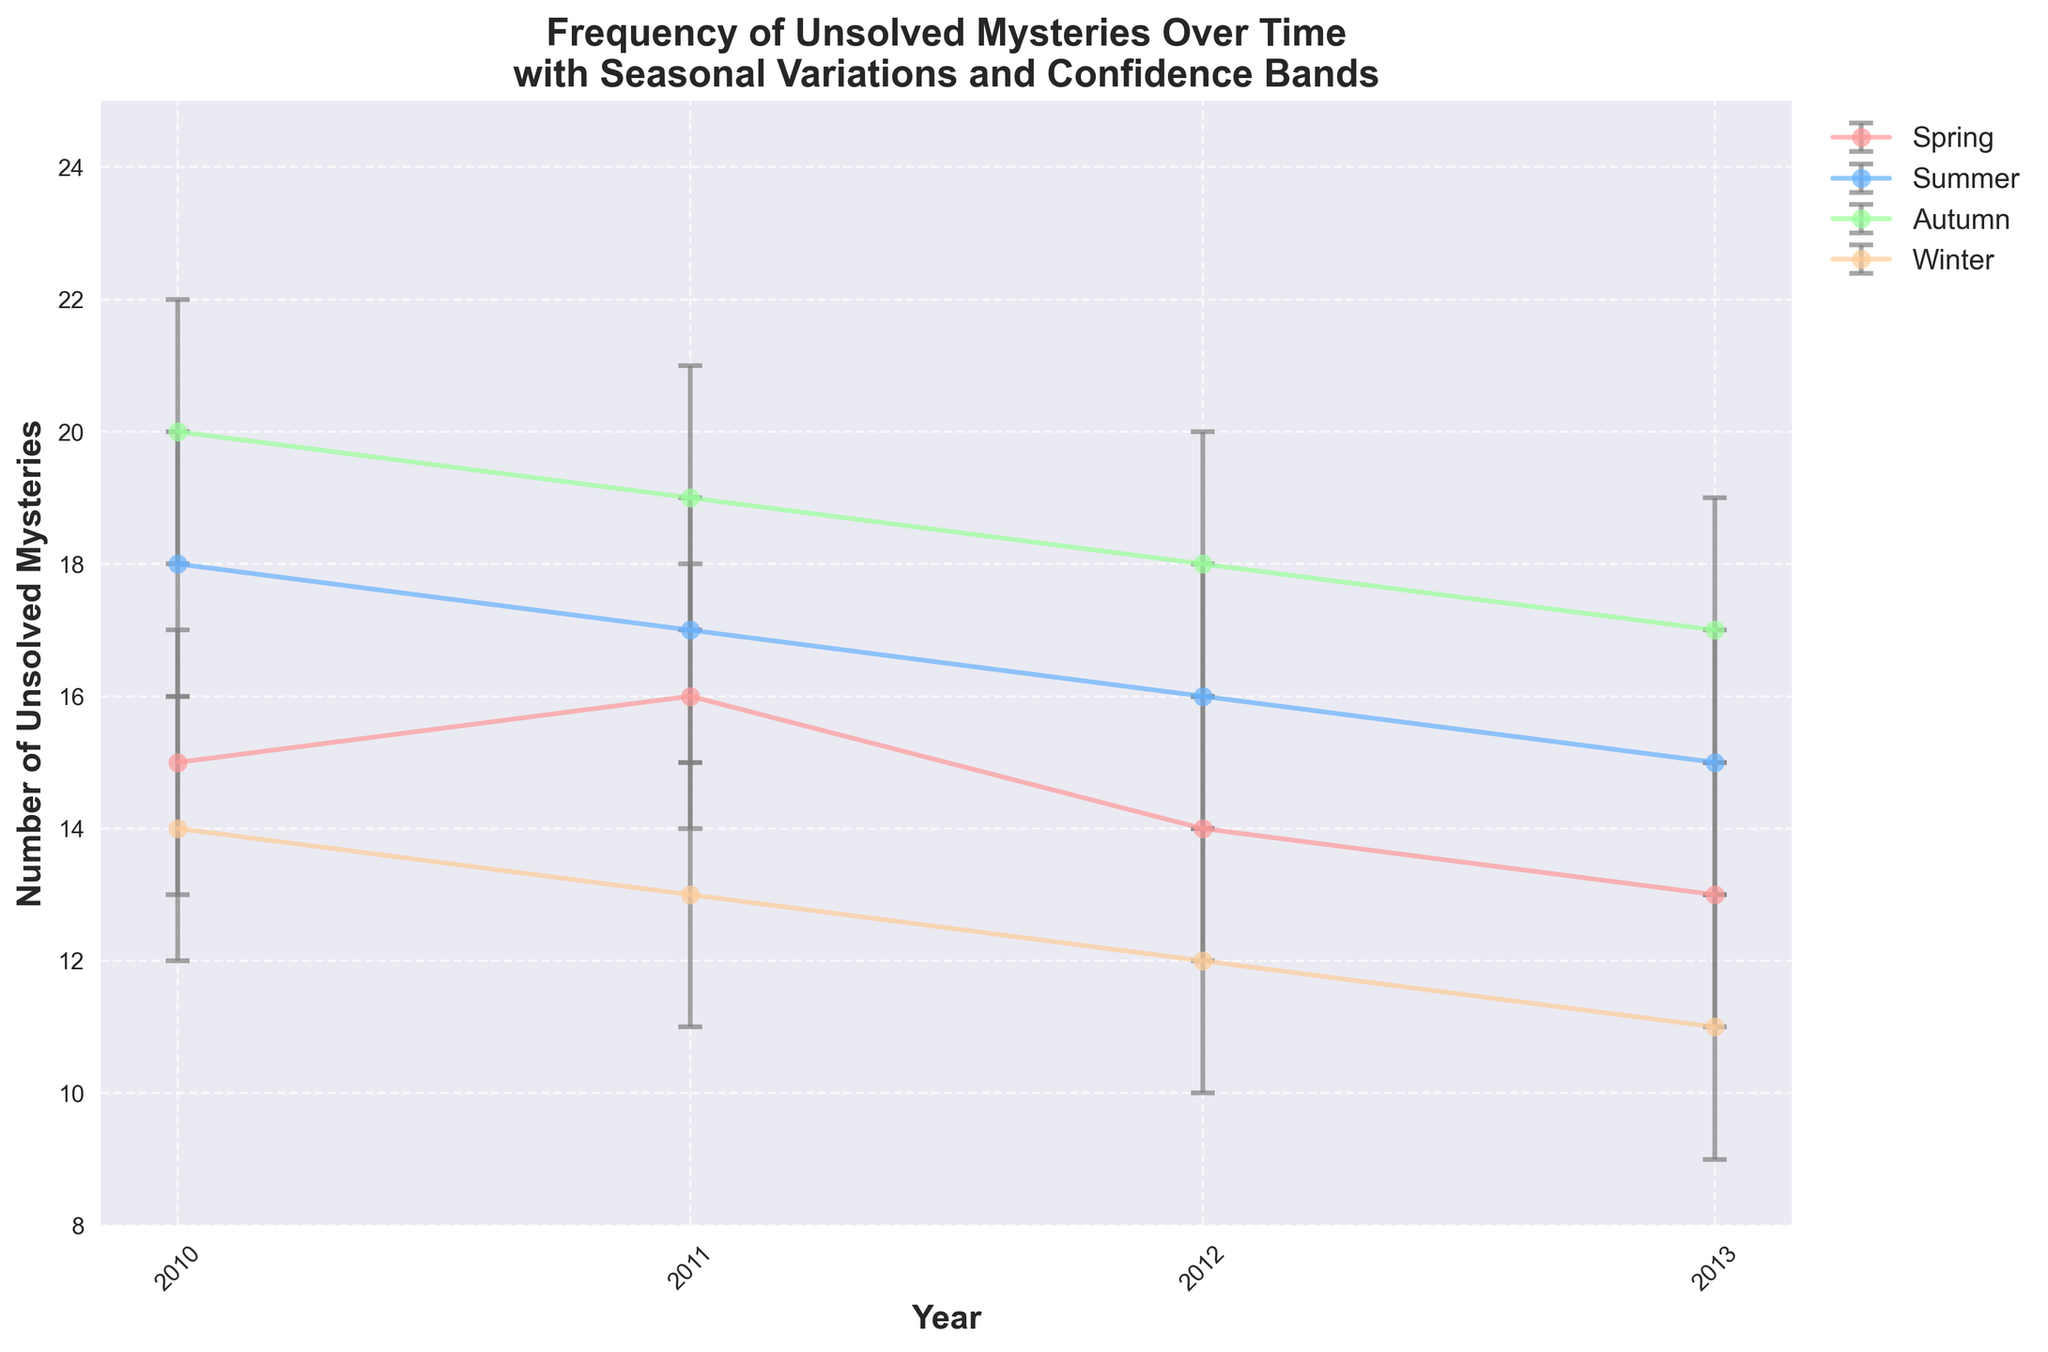What is the title of the figure? The title is at the top center of the figure, showing the overall purpose of the plot.
Answer: Frequency of Unsolved Mysteries Over Time with Seasonal Variations and Confidence Bands What is the y-axis label? Axis labels are typically found next to the respective axis, providing the measurement units and variable names. The y-axis label indicates what is being measured.
Answer: Number of Unsolved Mysteries In which year and season was the highest number of unsolved mysteries recorded? By looking at the peaks of the lines on the plot, find the highest data point and note its corresponding year and season from the legend and x-axis.
Answer: 2010 Autumn What is the general trend of unsolved mysteries in winter from 2010 to 2013? Following the line corresponding to winter, examine if the values are increasing, decreasing, or stable over the years.
Answer: Decreasing What is the average number of unsolved mysteries in Spring across all years shown? To find the average, add up the number of unsolved mysteries in Spring for all years and divide by the number of years. (15+16+14+13)/4
Answer: 14.5 Which season generally has the highest number of unsolved mysteries? By comparing the lines representing different seasons, identify which one generally has the highest values.
Answer: Autumn For Autumn, what is the range of confidence intervals from 2010 to 2013? Collect the upper and lower bounds of the confidence intervals for each year during Autumn, then calculate the range by subtracting the lowest lower bound from the highest upper bound. (22-17)
Answer: 5 How many seasons show a clear overall decrease in the number of unsolved mysteries from 2010 to 2013? Examine each line for trends over the years, counting how many show a clear downward trajectory.
Answer: 3 (Spring, Winter, Summer) Which year showed the least variations in unsolved mysteries across all seasons? For each year, check the vertical spread (difference between highest and lowest values) across the seasons and identify the smallest spread.
Answer: 2013 